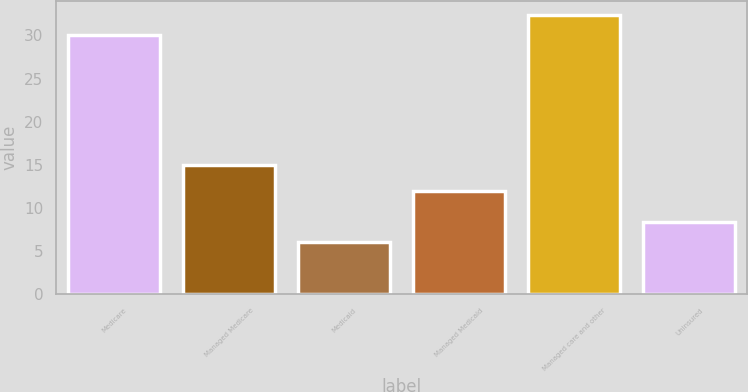<chart> <loc_0><loc_0><loc_500><loc_500><bar_chart><fcel>Medicare<fcel>Managed Medicare<fcel>Medicaid<fcel>Managed Medicaid<fcel>Managed care and other<fcel>Uninsured<nl><fcel>30<fcel>15<fcel>6<fcel>12<fcel>32.4<fcel>8.4<nl></chart> 